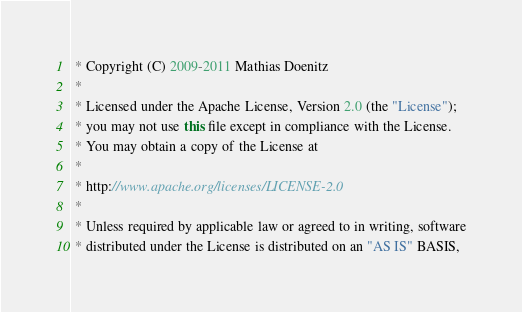Convert code to text. <code><loc_0><loc_0><loc_500><loc_500><_Java_> * Copyright (C) 2009-2011 Mathias Doenitz
 *
 * Licensed under the Apache License, Version 2.0 (the "License");
 * you may not use this file except in compliance with the License.
 * You may obtain a copy of the License at
 *
 * http://www.apache.org/licenses/LICENSE-2.0
 *
 * Unless required by applicable law or agreed to in writing, software
 * distributed under the License is distributed on an "AS IS" BASIS,</code> 